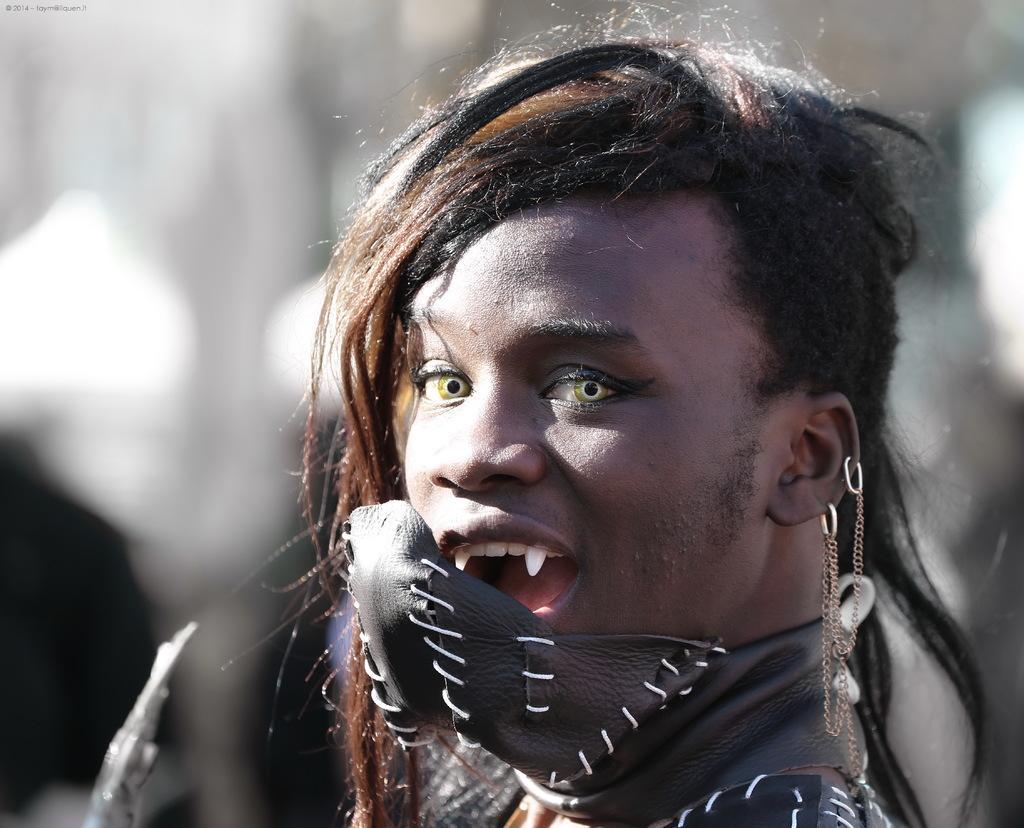Could you give a brief overview of what you see in this image? In this image we can see a person and in the background the image is blur. 